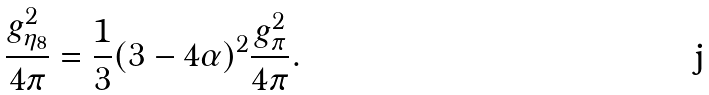Convert formula to latex. <formula><loc_0><loc_0><loc_500><loc_500>\frac { g _ { \eta _ { 8 } } ^ { 2 } } { 4 \pi } = \frac { 1 } { 3 } ( 3 - 4 \alpha ) ^ { 2 } \frac { g _ { \pi } ^ { 2 } } { 4 \pi } .</formula> 